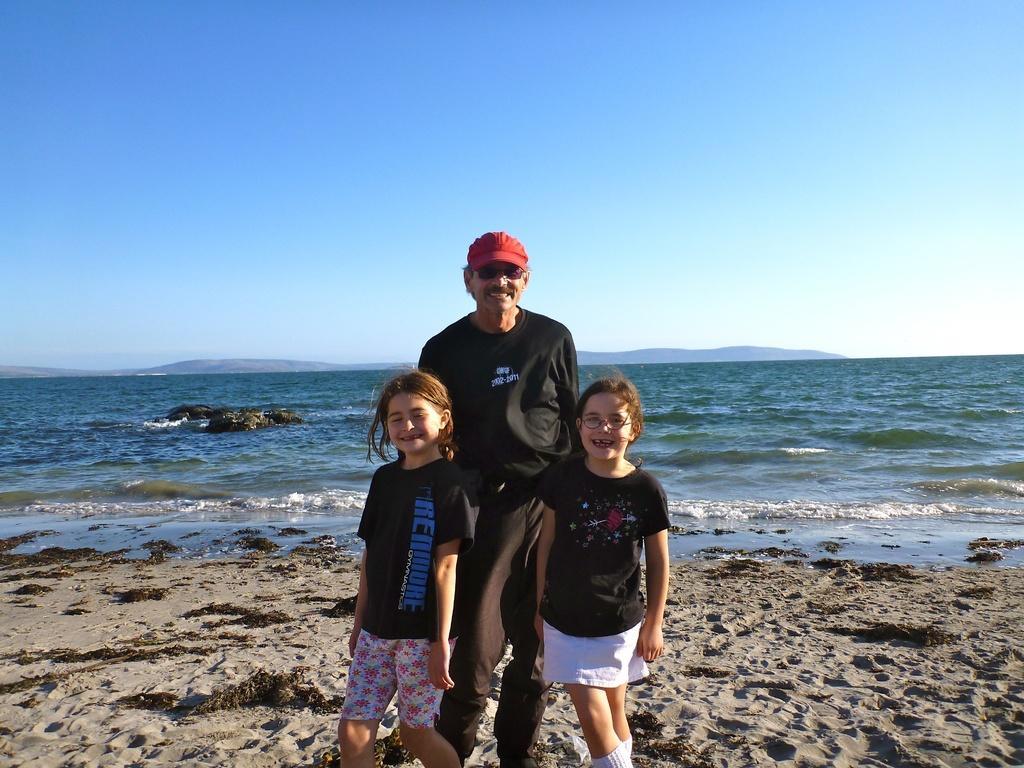Describe this image in one or two sentences. In the foreground of the image there is a man standing. There are two girls. In the background of the image there is water, sky. At the bottom of the image there is sand. 